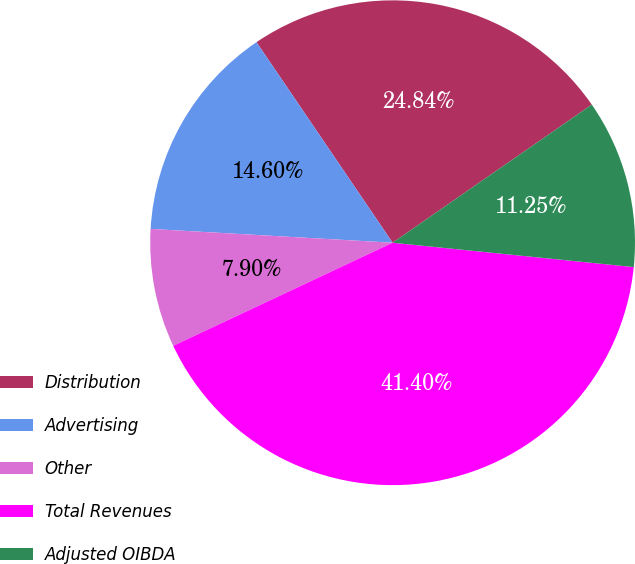Convert chart to OTSL. <chart><loc_0><loc_0><loc_500><loc_500><pie_chart><fcel>Distribution<fcel>Advertising<fcel>Other<fcel>Total Revenues<fcel>Adjusted OIBDA<nl><fcel>24.84%<fcel>14.6%<fcel>7.9%<fcel>41.4%<fcel>11.25%<nl></chart> 